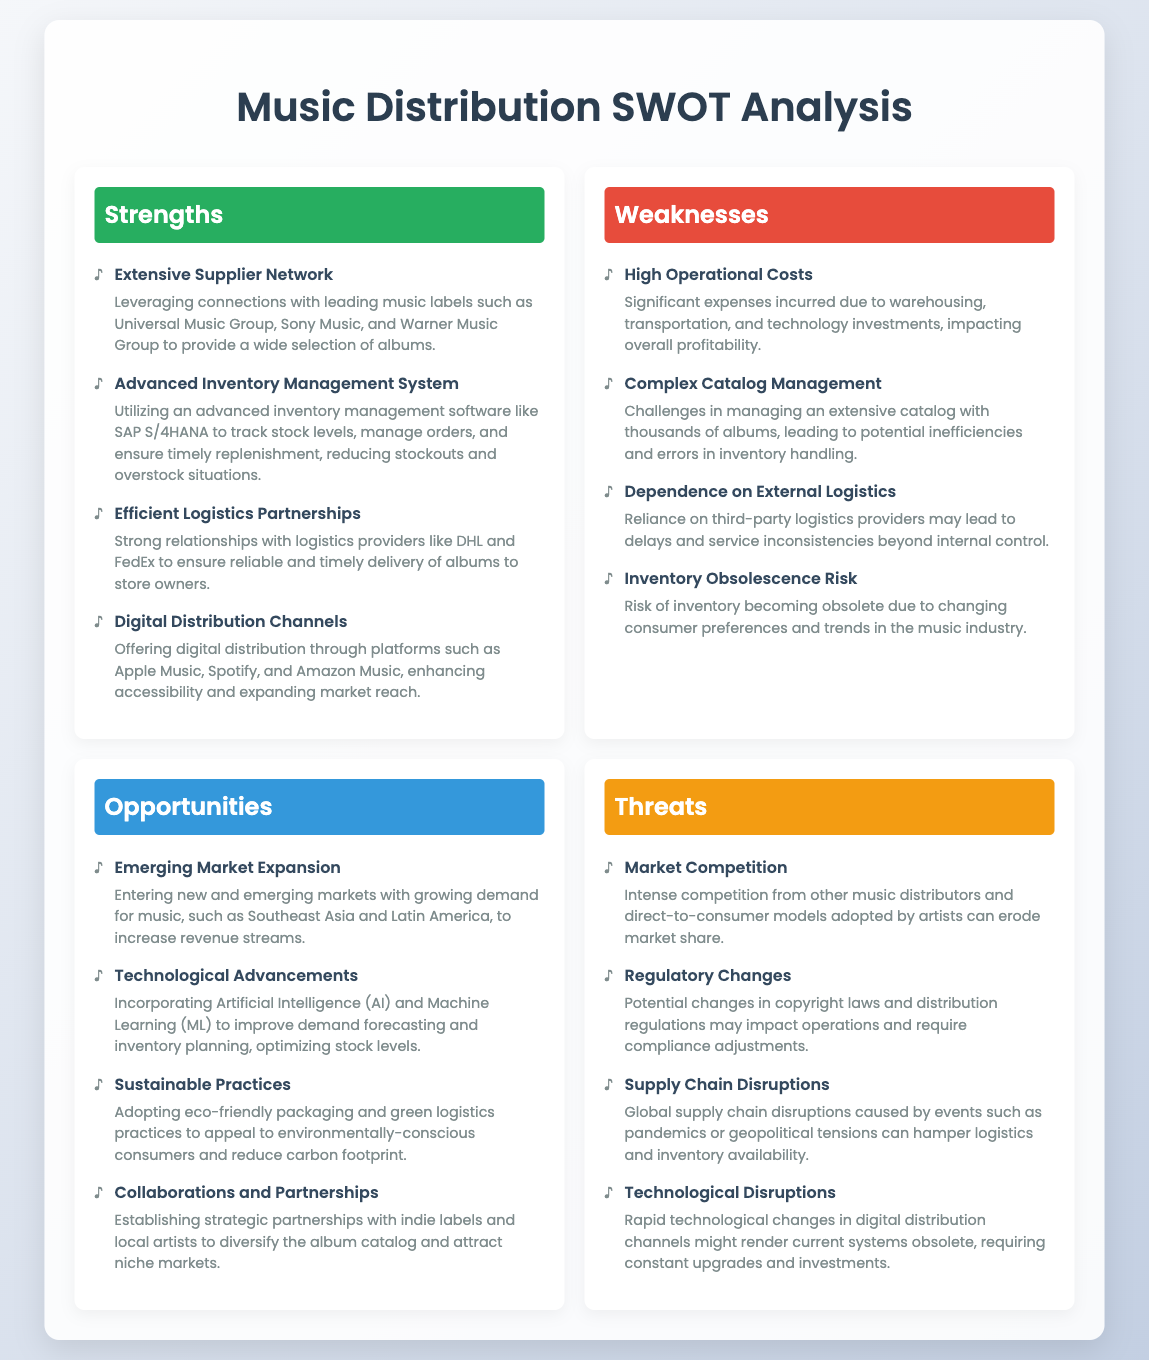What is a notable strength of the music distributor? The strength is identified as having an extensive supplier network that connects with leading music labels.
Answer: Extensive Supplier Network What software is used for inventory management? The document mentions that an advanced inventory management software like SAP S/4HANA is utilized.
Answer: SAP S/4HANA What is one weakness related to operational costs? The document states that high operational costs are significant expenses incurred due to various factors impacting profitability.
Answer: High Operational Costs Which market expansion is identified as an opportunity? The document highlights entering new and emerging markets, particularly in regions like Southeast Asia and Latin America.
Answer: Emerging Market Expansion What threat pertains to distribution regulations? Regulatory changes could impact operations and necessitate compliance adjustments as noted in the threats section.
Answer: Regulatory Changes How many weaknesses are listed in the SWOT analysis? There are four weaknesses outlined in the analysis regarding operational efficiency and inventory management.
Answer: Four What partnerships are emphasized as a strength? The document emphasizes strong relationships with logistics providers like DHL and FedEx for timely delivery.
Answer: Efficient Logistics Partnerships What technology is suggested for improving inventory planning? The document suggests incorporating Artificial Intelligence and Machine Learning for optimizing stock levels.
Answer: Artificial Intelligence and Machine Learning 